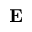Convert formula to latex. <formula><loc_0><loc_0><loc_500><loc_500>{ E }</formula> 